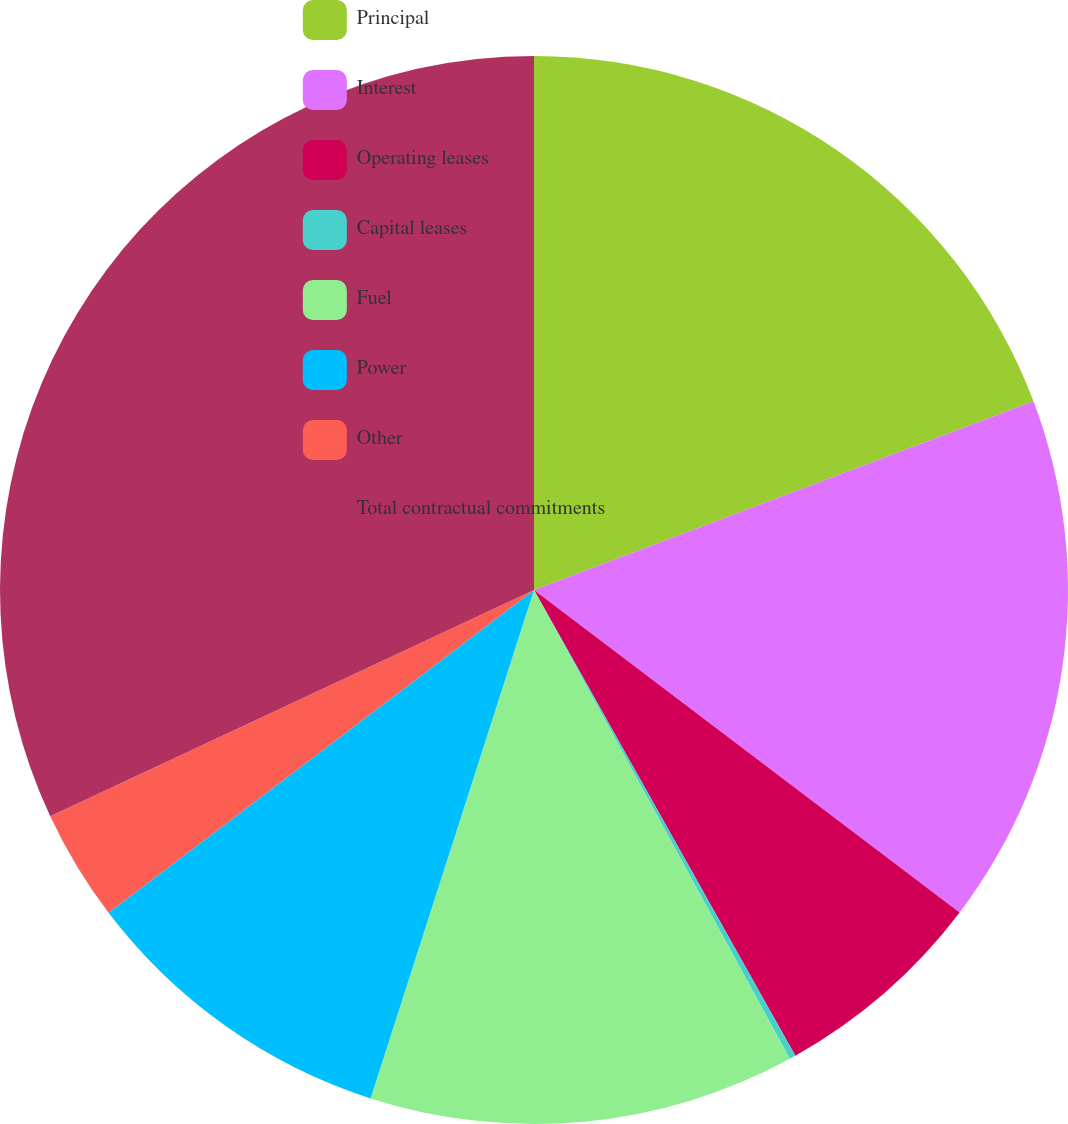Convert chart to OTSL. <chart><loc_0><loc_0><loc_500><loc_500><pie_chart><fcel>Principal<fcel>Interest<fcel>Operating leases<fcel>Capital leases<fcel>Fuel<fcel>Power<fcel>Other<fcel>Total contractual commitments<nl><fcel>19.25%<fcel>16.07%<fcel>6.54%<fcel>0.19%<fcel>12.9%<fcel>9.72%<fcel>3.37%<fcel>31.96%<nl></chart> 